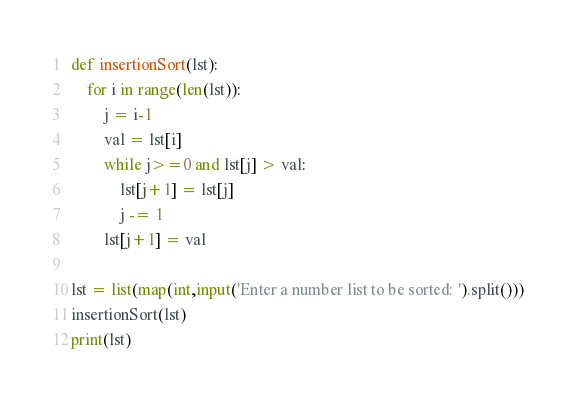Convert code to text. <code><loc_0><loc_0><loc_500><loc_500><_Python_>def insertionSort(lst):
    for i in range(len(lst)):
        j = i-1
        val = lst[i]
        while j>=0 and lst[j] > val:
            lst[j+1] = lst[j]
            j -= 1
        lst[j+1] = val

lst = list(map(int,input('Enter a number list to be sorted: ').split()))
insertionSort(lst)
print(lst)</code> 